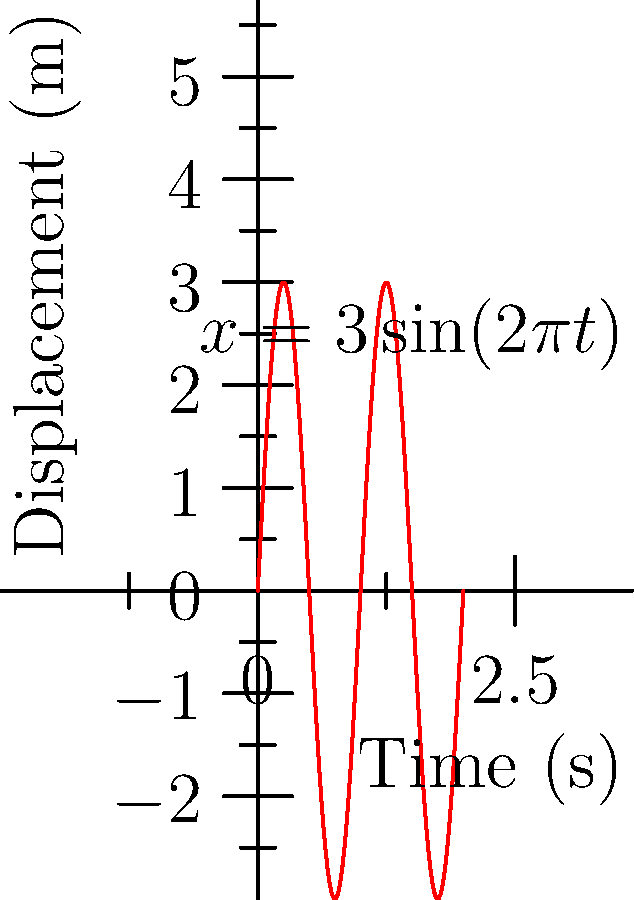The graph shows the displacement of a mass-spring system undergoing simple harmonic motion. Given that the mass of the object is 0.5 kg, determine the spring constant and the maximum force acting on the mass. Let's approach this step-by-step:

1) From the graph, we can identify that the amplitude $A = 3$ m and the period $T = 1$ s.

2) For a mass-spring system, the angular frequency $\omega$ is given by:
   $$\omega = \frac{2\pi}{T} = 2\pi \text{ rad/s}$$

3) The equation of motion for a simple harmonic oscillator is:
   $$x(t) = A\sin(\omega t)$$
   Here, $x(t) = 3\sin(2\pi t)$, which matches our graph.

4) For a mass-spring system, $\omega$ is related to the spring constant $k$ and mass $m$ by:
   $$\omega = \sqrt{\frac{k}{m}}$$

5) Rearranging this equation and substituting known values:
   $$k = m\omega^2 = 0.5 \times (2\pi)^2 = 19.74 \text{ N/m}$$

6) The maximum force occurs at the maximum displacement (amplitude). It's given by:
   $$F_{max} = kA = 19.74 \times 3 = 59.22 \text{ N}$$

Therefore, the spring constant is 19.74 N/m and the maximum force is 59.22 N.
Answer: Spring constant: 19.74 N/m; Maximum force: 59.22 N 